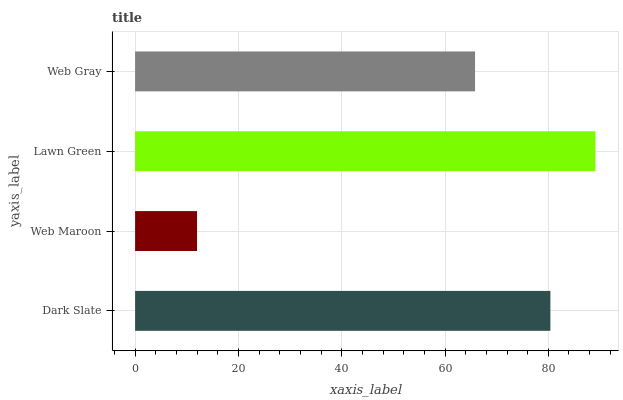Is Web Maroon the minimum?
Answer yes or no. Yes. Is Lawn Green the maximum?
Answer yes or no. Yes. Is Lawn Green the minimum?
Answer yes or no. No. Is Web Maroon the maximum?
Answer yes or no. No. Is Lawn Green greater than Web Maroon?
Answer yes or no. Yes. Is Web Maroon less than Lawn Green?
Answer yes or no. Yes. Is Web Maroon greater than Lawn Green?
Answer yes or no. No. Is Lawn Green less than Web Maroon?
Answer yes or no. No. Is Dark Slate the high median?
Answer yes or no. Yes. Is Web Gray the low median?
Answer yes or no. Yes. Is Web Gray the high median?
Answer yes or no. No. Is Web Maroon the low median?
Answer yes or no. No. 